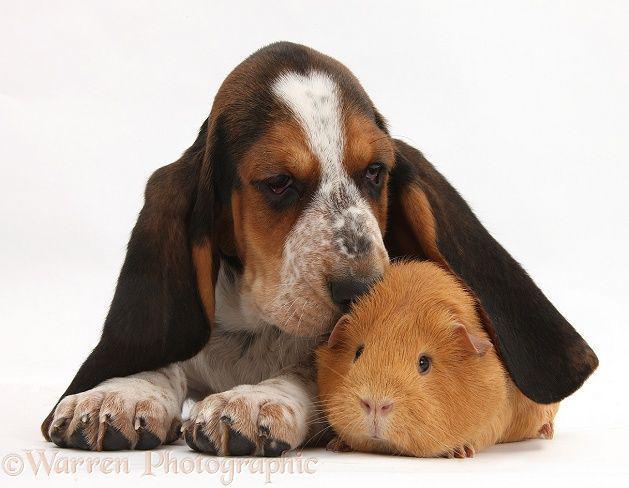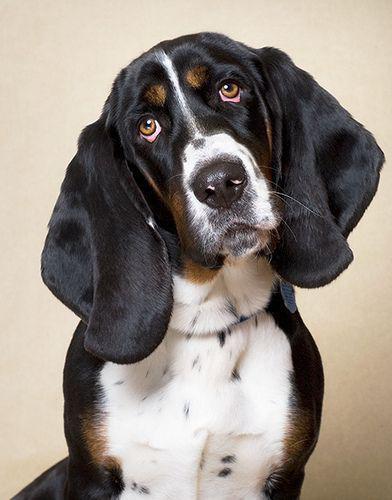The first image is the image on the left, the second image is the image on the right. For the images shown, is this caption "A non-collage image shows two animals side-by-side, at least one of them a basset hound." true? Answer yes or no. Yes. The first image is the image on the left, the second image is the image on the right. Given the left and right images, does the statement "Each photo contains a single dog." hold true? Answer yes or no. Yes. 